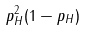Convert formula to latex. <formula><loc_0><loc_0><loc_500><loc_500>p _ { H } ^ { 2 } ( 1 - p _ { H } )</formula> 